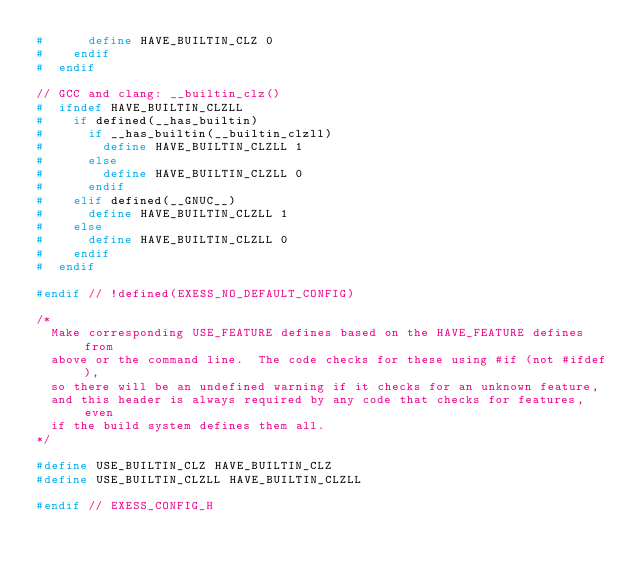<code> <loc_0><loc_0><loc_500><loc_500><_C_>#      define HAVE_BUILTIN_CLZ 0
#    endif
#  endif

// GCC and clang: __builtin_clz()
#  ifndef HAVE_BUILTIN_CLZLL
#    if defined(__has_builtin)
#      if __has_builtin(__builtin_clzll)
#        define HAVE_BUILTIN_CLZLL 1
#      else
#        define HAVE_BUILTIN_CLZLL 0
#      endif
#    elif defined(__GNUC__)
#      define HAVE_BUILTIN_CLZLL 1
#    else
#      define HAVE_BUILTIN_CLZLL 0
#    endif
#  endif

#endif // !defined(EXESS_NO_DEFAULT_CONFIG)

/*
  Make corresponding USE_FEATURE defines based on the HAVE_FEATURE defines from
  above or the command line.  The code checks for these using #if (not #ifdef),
  so there will be an undefined warning if it checks for an unknown feature,
  and this header is always required by any code that checks for features, even
  if the build system defines them all.
*/

#define USE_BUILTIN_CLZ HAVE_BUILTIN_CLZ
#define USE_BUILTIN_CLZLL HAVE_BUILTIN_CLZLL

#endif // EXESS_CONFIG_H
</code> 